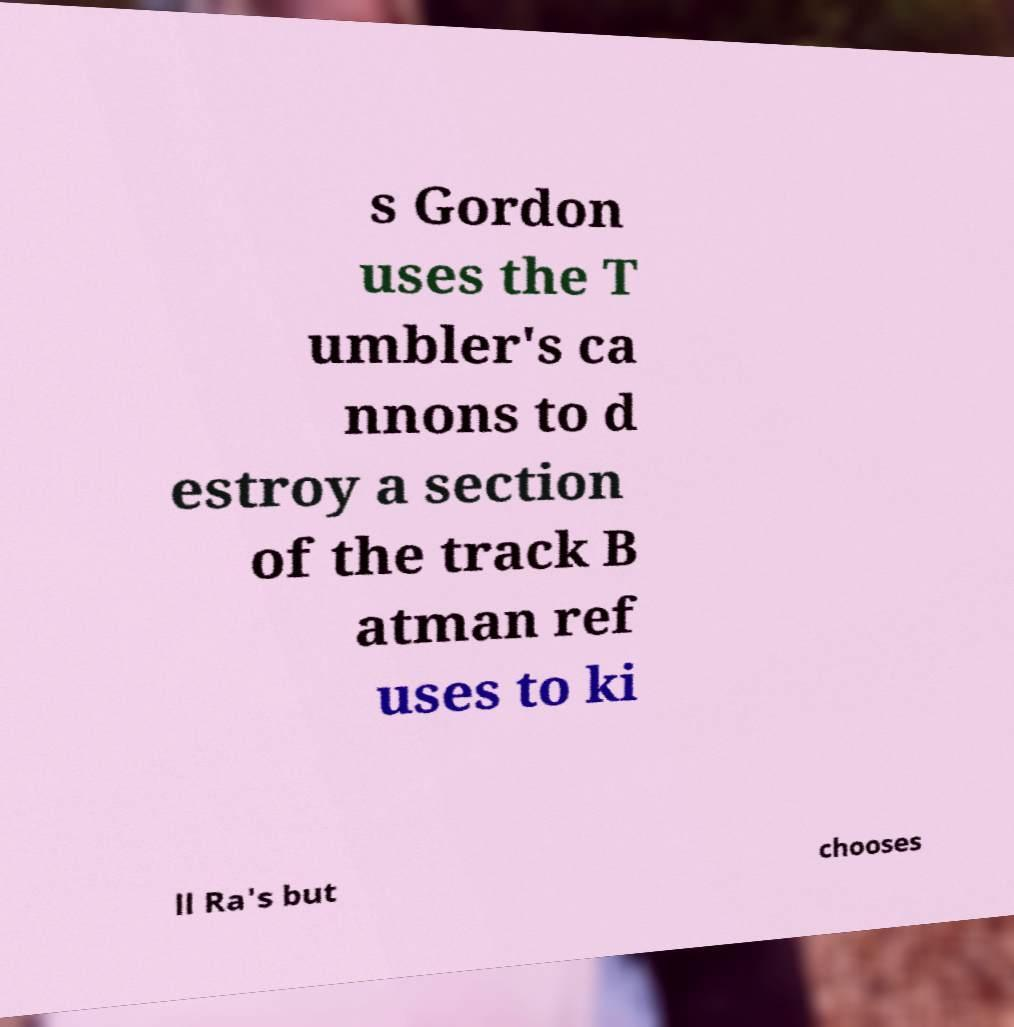Can you read and provide the text displayed in the image?This photo seems to have some interesting text. Can you extract and type it out for me? s Gordon uses the T umbler's ca nnons to d estroy a section of the track B atman ref uses to ki ll Ra's but chooses 